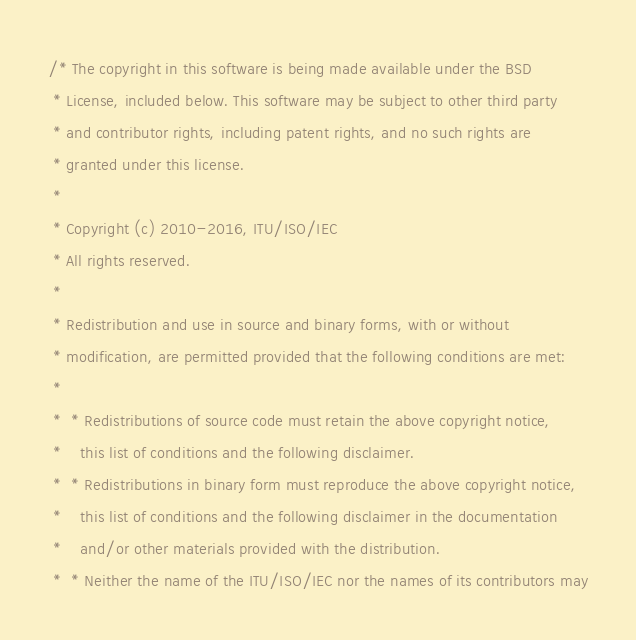<code> <loc_0><loc_0><loc_500><loc_500><_C++_>/* The copyright in this software is being made available under the BSD
 * License, included below. This software may be subject to other third party
 * and contributor rights, including patent rights, and no such rights are
 * granted under this license.
 *
 * Copyright (c) 2010-2016, ITU/ISO/IEC
 * All rights reserved.
 *
 * Redistribution and use in source and binary forms, with or without
 * modification, are permitted provided that the following conditions are met:
 *
 *  * Redistributions of source code must retain the above copyright notice,
 *    this list of conditions and the following disclaimer.
 *  * Redistributions in binary form must reproduce the above copyright notice,
 *    this list of conditions and the following disclaimer in the documentation
 *    and/or other materials provided with the distribution.
 *  * Neither the name of the ITU/ISO/IEC nor the names of its contributors may</code> 